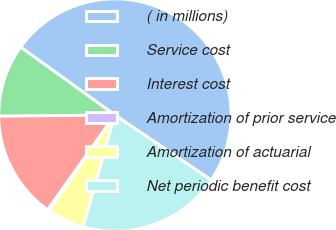Convert chart. <chart><loc_0><loc_0><loc_500><loc_500><pie_chart><fcel>( in millions)<fcel>Service cost<fcel>Interest cost<fcel>Amortization of prior service<fcel>Amortization of actuarial<fcel>Net periodic benefit cost<nl><fcel>49.51%<fcel>10.1%<fcel>15.02%<fcel>0.25%<fcel>5.17%<fcel>19.95%<nl></chart> 